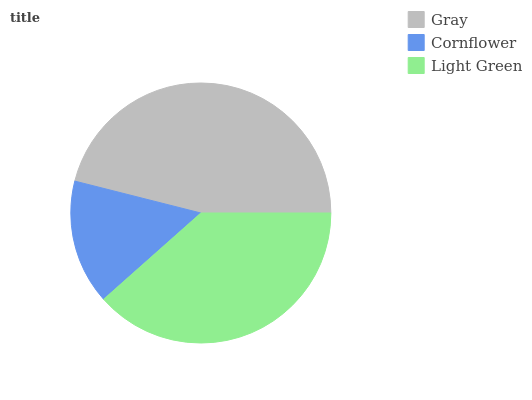Is Cornflower the minimum?
Answer yes or no. Yes. Is Gray the maximum?
Answer yes or no. Yes. Is Light Green the minimum?
Answer yes or no. No. Is Light Green the maximum?
Answer yes or no. No. Is Light Green greater than Cornflower?
Answer yes or no. Yes. Is Cornflower less than Light Green?
Answer yes or no. Yes. Is Cornflower greater than Light Green?
Answer yes or no. No. Is Light Green less than Cornflower?
Answer yes or no. No. Is Light Green the high median?
Answer yes or no. Yes. Is Light Green the low median?
Answer yes or no. Yes. Is Cornflower the high median?
Answer yes or no. No. Is Cornflower the low median?
Answer yes or no. No. 